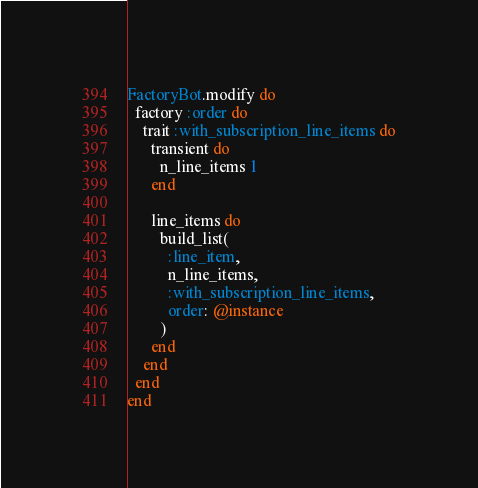<code> <loc_0><loc_0><loc_500><loc_500><_Ruby_>FactoryBot.modify do
  factory :order do
    trait :with_subscription_line_items do
      transient do
        n_line_items 1
      end

      line_items do
        build_list(
          :line_item,
          n_line_items,
          :with_subscription_line_items,
          order: @instance
        )
      end
    end
  end
end
</code> 